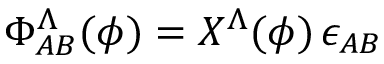Convert formula to latex. <formula><loc_0><loc_0><loc_500><loc_500>\Phi _ { A B } ^ { \Lambda } ( \phi ) = X ^ { \Lambda } ( \phi ) \, \epsilon _ { A B }</formula> 